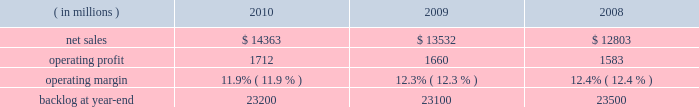Operating profit for the segment increased 10% ( 10 % ) in 2009 compared to 2008 .
The growth in operating profit primarily was due to increases in air mobility and other aeronautics programs .
The $ 70 million increase in air mobility 2019s operating profit primarily was due to the higher volume on c-130j deliveries and c-130 support programs .
In other aeronautics programs , operating profit increased $ 120 million , which mainly was attributable to improved performance in sustainment activities and higher volume on p-3 programs .
Additionally , the increase in operating profit included the favorable restructuring of a p-3 modification contract in 2009 .
Combat aircraft 2019s operating profit decreased $ 22 million during the year primarily due to a reduction in the level of favorable performance adjustments on f-16 programs in 2009 compared to 2008 and lower volume on other combat aircraft programs .
These decreases more than offset increased operating profit resulting from higher volume and improved performance on the f-35 program and an increase in the level of favorable performance adjustments on the f-22 program in 2009 compared to 2008 .
The remaining change in operating profit is attributable to a decrease in other income , net , between the comparable periods .
Backlog increased in 2010 compared to 2009 mainly due to orders exceeding sales on the c-130j , f-35 and c-5 programs , which partially were offset by higher sales volume compared to new orders on the f-22 program in 2010 .
Backlog decreased in 2009 compared to 2008 mainly due to sales exceeding orders on the f-22 and f-35 programs , which partially were offset by orders exceeding sales on the c-130j and c-5 programs .
We expect aeronautics will have sales growth in the upper single digit percentage range for 2011 as compared to 2010 .
This increase primarily is driven by growth on f-35 low rate initial production ( lrip ) contracts , c-130j and c-5 rerp programs that will more than offset a decline on the f-22 program .
Operating profit is projected to increase at a mid single digit percentage rate above 2010 levels , resulting in a decline in operating margins between the years .
Similar to the relationship of operating margins from 2009 to 2010 discussed above , the expected operating margin decrease from 2010 to 2011 reflects the trend of aeronautics performing more development and initial production work on the f-35 program and is performing less work on more mature programs such as the f-22 and f-16 , even though sales are expected to increase in 2011 relative to 2010 .
Electronic systems our electronic systems business segment manages complex programs and designs , develops , produces , and integrates hardware and software solutions to ensure the mission readiness of armed forces and government agencies worldwide .
The segment 2019s three lines of business are mission systems & sensors ( ms2 ) , missiles & fire control ( m&fc ) , and global training & logistics ( gt&l ) .
With such a broad portfolio of programs to provide products and services , many of its activities involve a combination of both development and production contracts with varying delivery schedules .
Some of its more significant programs , including the thaad system , the aegis weapon system , and the littoral combat ship program , demonstrate the diverse products and services electronic systems provides .
Electronic systems 2019 operating results included the following : ( in millions ) 2010 2009 2008 .
Net sales for electronic systems increased by 6% ( 6 % ) in 2010 compared to 2009 .
Sales increased in all three lines of business during the year .
The $ 421 million increase at gt&l primarily was due to growth on readiness and stability operations , which partially was offset by lower volume on simulation & training programs .
The $ 316 million increase at m&fc primarily was due to higher volume on tactical missile and air defense programs , which partially was offset by a decline in volume on fire control systems .
The $ 94 million increase at ms2 mainly was due to higher volume on surface naval warfare , ship & aviation systems , and radar systems programs , which partially was offset by lower volume on undersea warfare programs .
Net sales for electronic systems increased by 6% ( 6 % ) in 2009 compared to 2008 .
Sales increases in m&fc and gt&l more than offset a decline in ms2 .
The $ 429 million increase in sales at m&fc primarily was due to growth on tactical missile programs and fire control systems .
The $ 355 million increase at gt&l primarily was due to growth on simulation and training activities and readiness and stability operations .
The increase in simulation and training also included sales from the first quarter 2009 acquisition of universal systems and technology , inc .
The $ 55 million decrease at ms2 mainly was due to lower volume on ship & aviation systems and undersea warfare programs , which partially were offset by higher volume on radar systems and surface naval warfare programs. .
What were average operating profit for electronic systems in millions from 2008 to 2010? 
Computations: table_average(operating profit, none)
Answer: 1651.66667. 